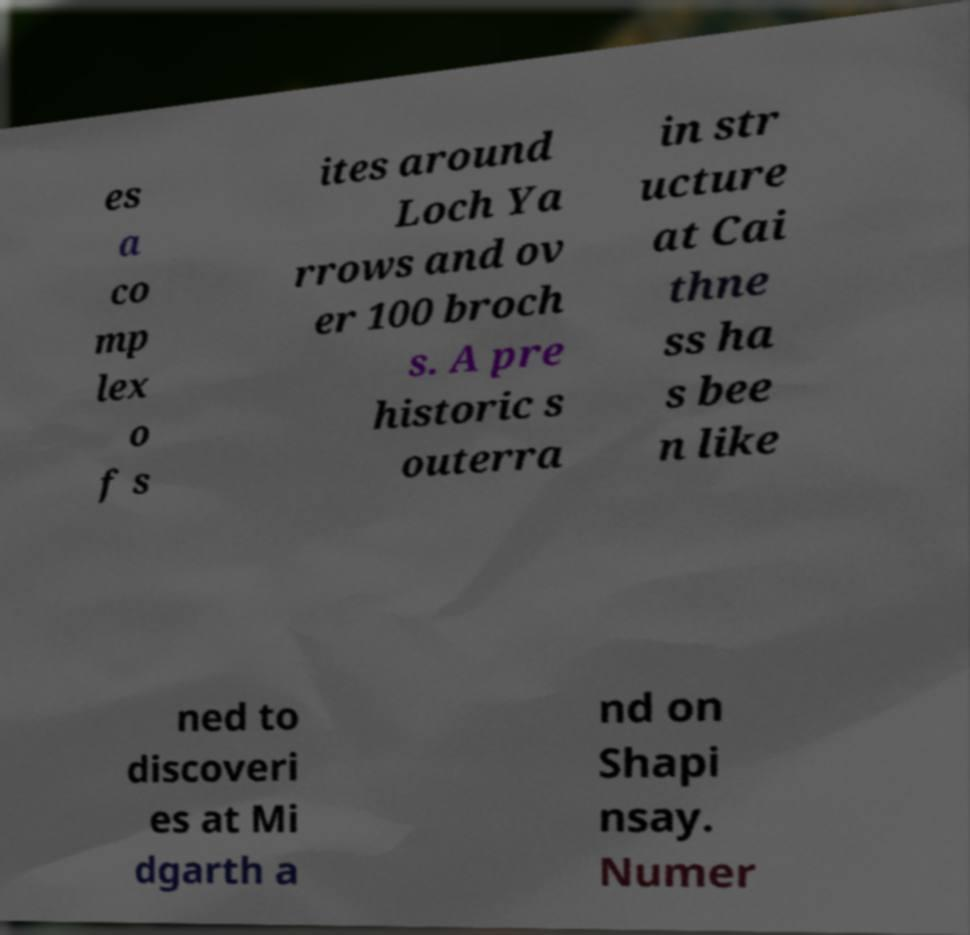There's text embedded in this image that I need extracted. Can you transcribe it verbatim? es a co mp lex o f s ites around Loch Ya rrows and ov er 100 broch s. A pre historic s outerra in str ucture at Cai thne ss ha s bee n like ned to discoveri es at Mi dgarth a nd on Shapi nsay. Numer 